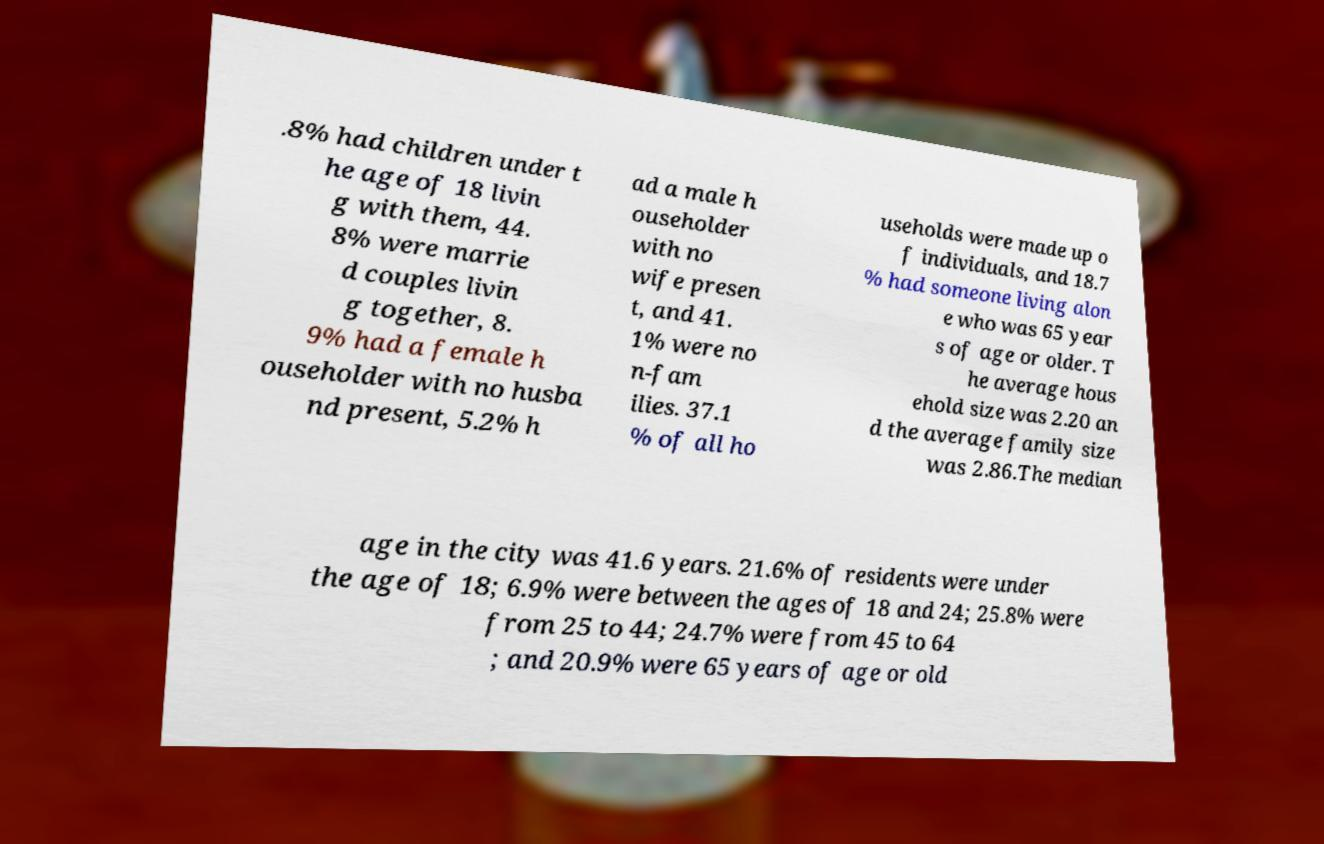What messages or text are displayed in this image? I need them in a readable, typed format. .8% had children under t he age of 18 livin g with them, 44. 8% were marrie d couples livin g together, 8. 9% had a female h ouseholder with no husba nd present, 5.2% h ad a male h ouseholder with no wife presen t, and 41. 1% were no n-fam ilies. 37.1 % of all ho useholds were made up o f individuals, and 18.7 % had someone living alon e who was 65 year s of age or older. T he average hous ehold size was 2.20 an d the average family size was 2.86.The median age in the city was 41.6 years. 21.6% of residents were under the age of 18; 6.9% were between the ages of 18 and 24; 25.8% were from 25 to 44; 24.7% were from 45 to 64 ; and 20.9% were 65 years of age or old 